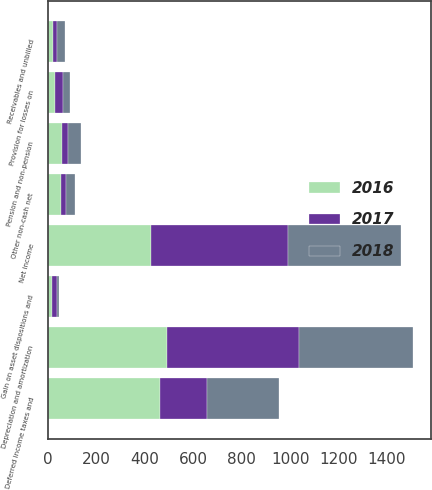<chart> <loc_0><loc_0><loc_500><loc_500><stacked_bar_chart><ecel><fcel>Net income<fcel>Depreciation and amortization<fcel>Deferred income taxes and<fcel>Provision for losses on<fcel>Gain on asset dispositions and<fcel>Pension and non-pension<fcel>Other non-cash net<fcel>Receivables and unbilled<nl><fcel>2017<fcel>565<fcel>545<fcel>195<fcel>33<fcel>20<fcel>23<fcel>20<fcel>17<nl><fcel>2016<fcel>426<fcel>492<fcel>462<fcel>29<fcel>16<fcel>57<fcel>54<fcel>21<nl><fcel>2018<fcel>468<fcel>470<fcel>295<fcel>27<fcel>10<fcel>54<fcel>36<fcel>31<nl></chart> 